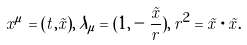<formula> <loc_0><loc_0><loc_500><loc_500>x ^ { \mu } = ( t , \vec { x } ) , \, \lambda _ { \mu } = ( 1 , - \frac { \vec { x } } { r } ) , \, r ^ { 2 } = \vec { x } \cdot \vec { x } .</formula> 